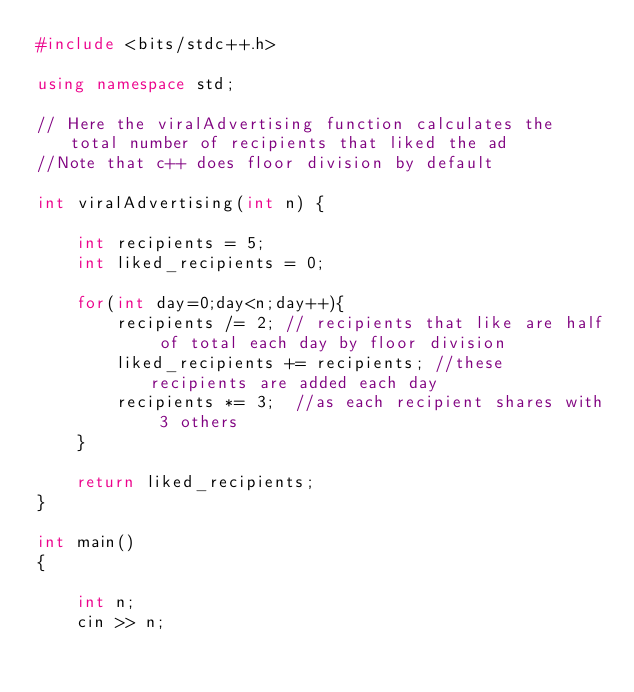<code> <loc_0><loc_0><loc_500><loc_500><_C++_>#include <bits/stdc++.h>

using namespace std;

// Here the viralAdvertising function calculates the total number of recipients that liked the ad
//Note that c++ does floor division by default

int viralAdvertising(int n) {

    int recipients = 5;
    int liked_recipients = 0;

    for(int day=0;day<n;day++){
        recipients /= 2; // recipients that like are half of total each day by floor division
        liked_recipients += recipients; //these recipients are added each day
        recipients *= 3;  //as each recipient shares with 3 others
    }

    return liked_recipients;
}

int main()
{

    int n;
    cin >> n;
</code> 